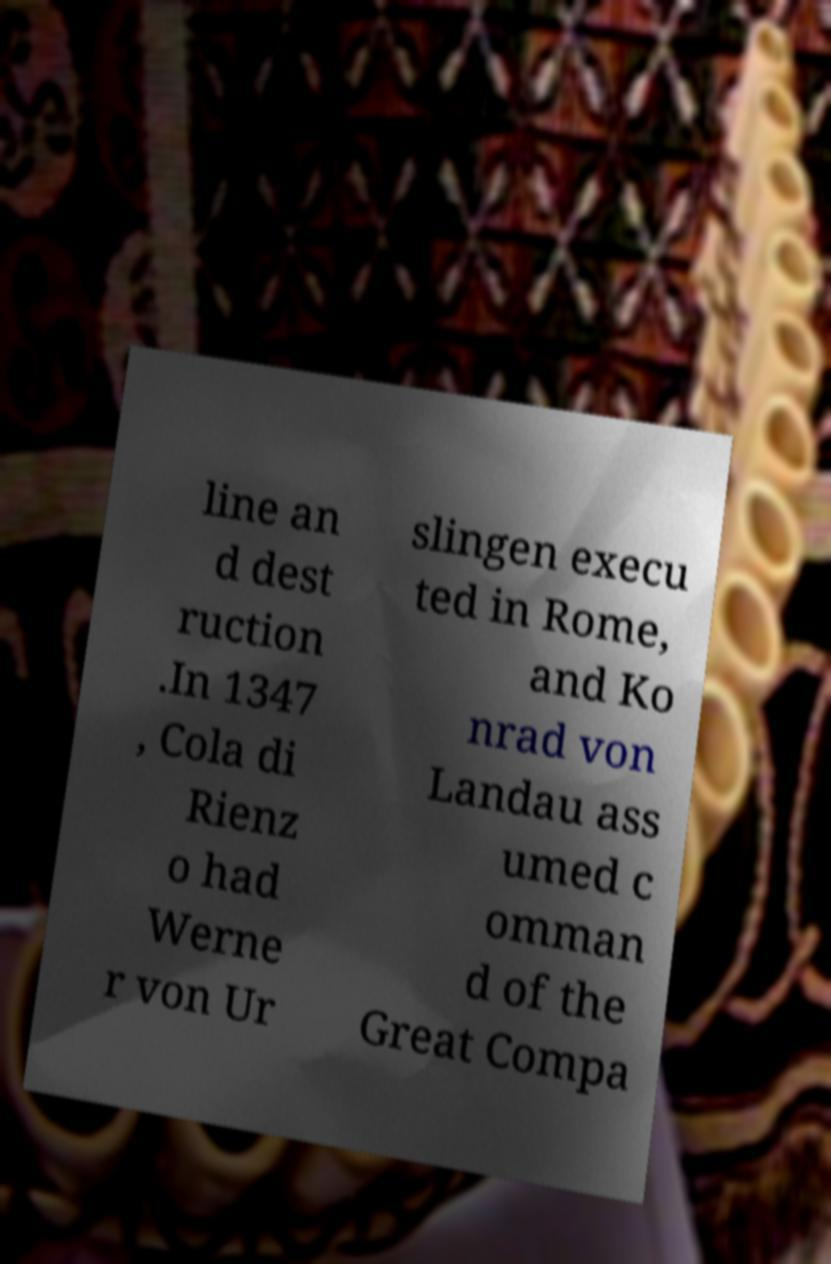I need the written content from this picture converted into text. Can you do that? line an d dest ruction .In 1347 , Cola di Rienz o had Werne r von Ur slingen execu ted in Rome, and Ko nrad von Landau ass umed c omman d of the Great Compa 